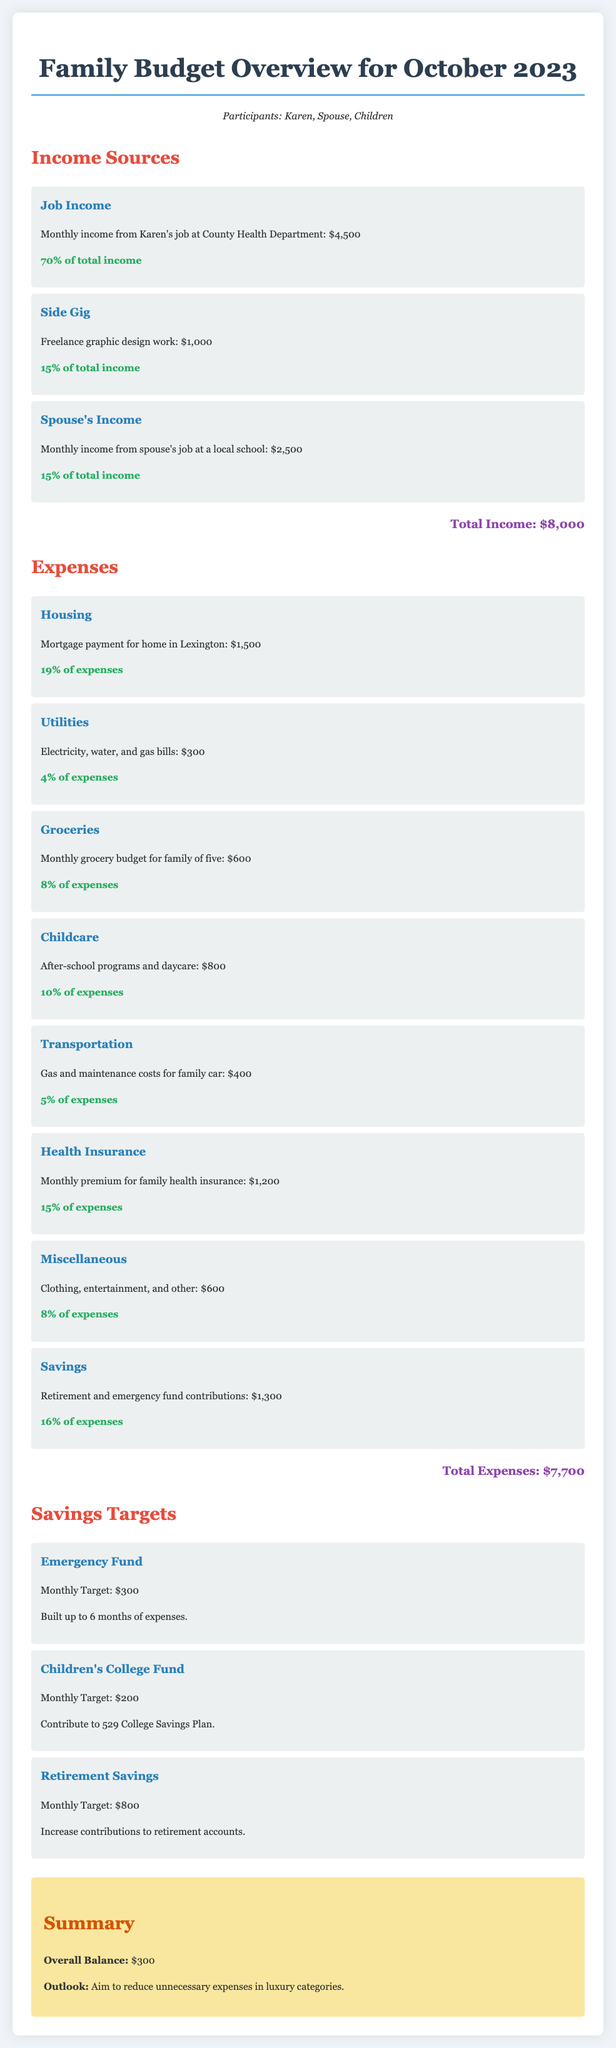what is the total income? The total income is the sum of all income sources listed in the document, which is $4,500 + $1,000 + $2,500 = $8,000.
Answer: $8,000 how much is allocated to groceries? The document specifies the monthly grocery budget for the family, which is $600.
Answer: $600 what is the monthly target for the Emergency Fund? The monthly target for the Emergency Fund is explicitly stated in the document.
Answer: $300 what percentage of expenses is spent on housing? The document indicates that the housing expenditure represents 19% of the total expenses.
Answer: 19% what is the overall balance for the month? The overall balance is provided as the difference between total income and total expenses, which is $8,000 - $7,700 = $300.
Answer: $300 how much does Karen earn from her job? The document specifies Karen's monthly income from her job at the County Health Department, which is $4,500.
Answer: $4,500 what type of work contributes to the side gig income? The side gig income arises from freelance work, specifically mentioned as graphic design in the document.
Answer: graphic design how much is spent on childcare? The document denotes the expenditure on after-school programs and daycare as $800.
Answer: $800 what is the total expense amount? The total expenses are calculated by summing all the expense categories stated in the document, which equals to $7,700.
Answer: $7,700 